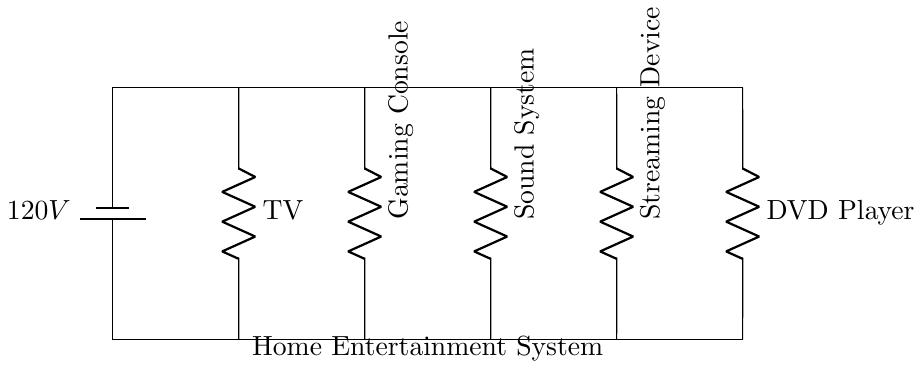What is the total voltage in the circuit? The total voltage of the circuit is 120V, as indicated by the battery in the diagram.
Answer: 120V What components are connected in this circuit? The components in this circuit include a TV, Gaming Console, Sound System, Streaming Device, and DVD Player, as labeled in the diagram.
Answer: TV, Gaming Console, Sound System, Streaming Device, DVD Player How many components are connected in parallel? There are five components connected in parallel in this circuit: TV, Gaming Console, Sound System, Streaming Device, and DVD Player.
Answer: Five Which component is represented at the leftmost position? The TV is the component at the leftmost position, as seen in the diagram where it is the first labeled resistor from the left.
Answer: TV What is unique about the circuit type? The unique aspect of this parallel circuit is that each component receives the same voltage of 120V, allowing them to operate independently.
Answer: Same voltage What happens to the voltage across each component in parallel? In a parallel circuit, the voltage across each component remains the same, which is 120V in this case, irrespective of the individual component's resistance.
Answer: Remains the same What is the purpose of using a parallel circuit for a home entertainment system? The purpose is to allow each audio and video component to operate independently without affecting the others, even if one component fails.
Answer: Independent operation 